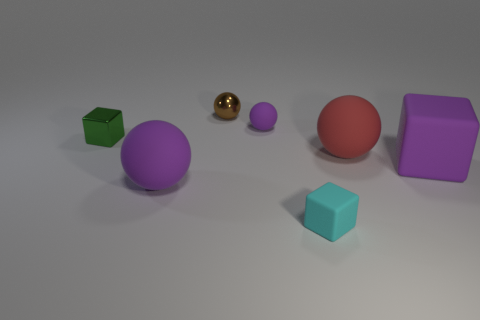Add 2 big green metallic cylinders. How many objects exist? 9 Subtract all large purple matte spheres. How many spheres are left? 3 Subtract 1 spheres. How many spheres are left? 3 Add 5 red balls. How many red balls exist? 6 Subtract all brown balls. How many balls are left? 3 Subtract 0 red cylinders. How many objects are left? 7 Subtract all balls. How many objects are left? 3 Subtract all gray balls. Subtract all red cubes. How many balls are left? 4 Subtract all red cubes. How many gray balls are left? 0 Subtract all small things. Subtract all red balls. How many objects are left? 2 